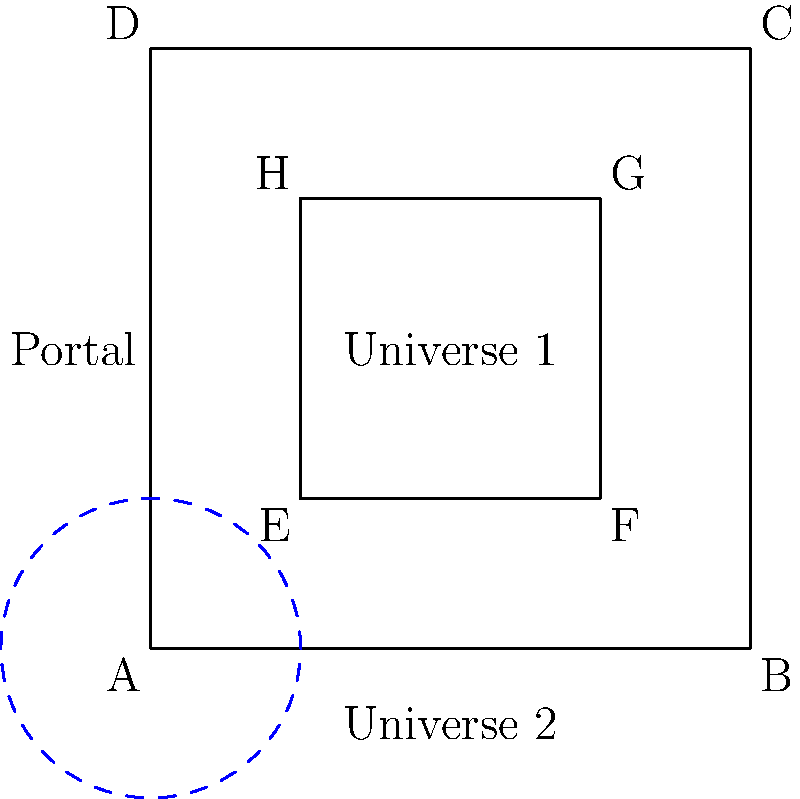In a spiraling labyrinth connecting parallel universes, the outer square ABCD represents Universe 1, while the inner square EFGH represents a portal to Universe 2. If the area of Universe 1 is 16 square units and the area of the portal is 4 square units, what is the ratio of the circumference of the circular portal (represented by the dashed blue line) to the perimeter of Universe 1? Let's approach this step-by-step:

1) The area of Universe 1 (outer square ABCD) is 16 square units.
   Side length of ABCD = $\sqrt{16} = 4$ units

2) The perimeter of Universe 1 = $4 * 4 = 16$ units

3) The area of the portal (inner square EFGH) is 4 square units.
   Side length of EFGH = $\sqrt{4} = 2$ units

4) The circular portal is inscribed in square EFGH.
   Its diameter is equal to the side length of EFGH, which is 2 units.
   Thus, its radius is 1 unit.

5) The circumference of the circular portal = $2\pi r = 2\pi * 1 = 2\pi$ units

6) The ratio of the circumference of the circular portal to the perimeter of Universe 1:
   $\frac{2\pi}{16} = \frac{\pi}{8}$
Answer: $\frac{\pi}{8}$ 